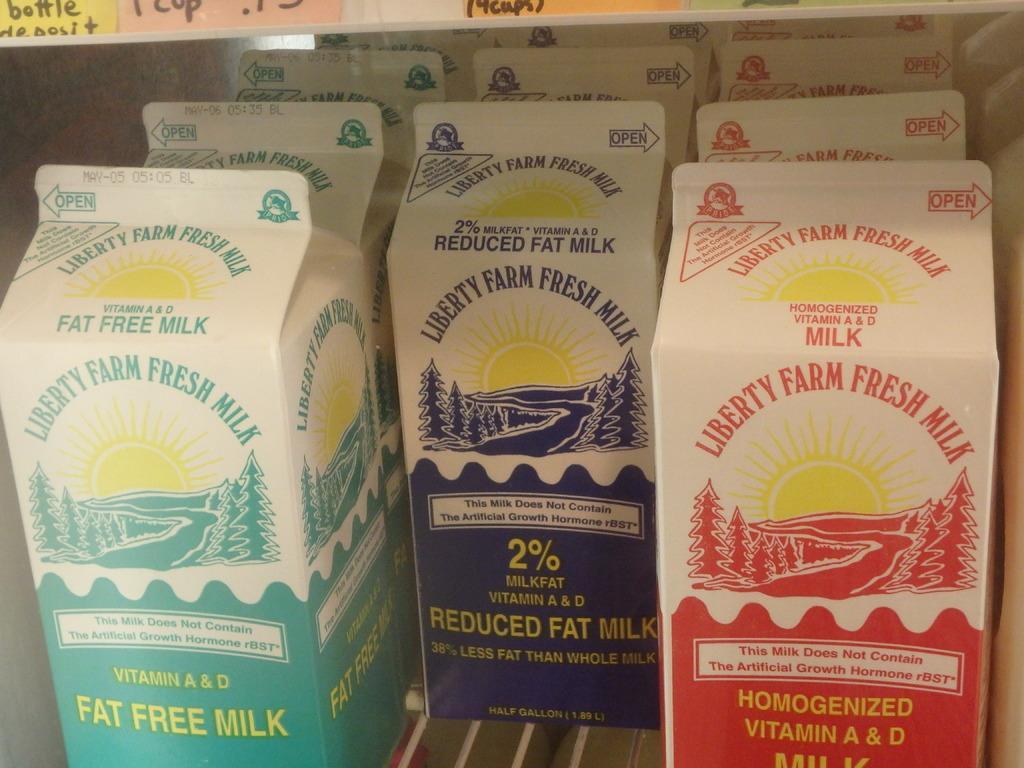Can you describe this image briefly? In the image on the tray to the left corner there is a green color milk packet. In the middle of the image on the tray there is a blue colored milk bottles. And to the right side of the image there are red color milk packets. On the packets there are labels and names on it. And to the top corner of the image there are color papers with something written on it. 